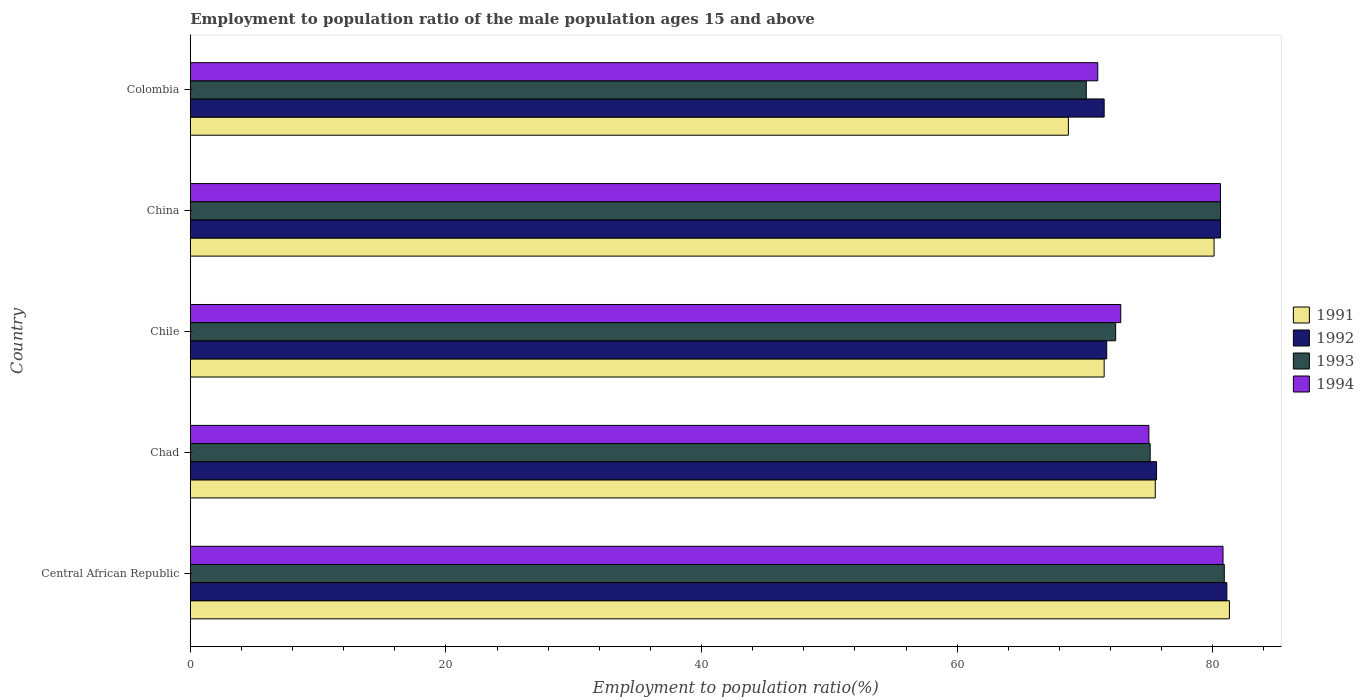How many different coloured bars are there?
Ensure brevity in your answer.  4. Are the number of bars per tick equal to the number of legend labels?
Ensure brevity in your answer.  Yes. Are the number of bars on each tick of the Y-axis equal?
Provide a short and direct response. Yes. In how many cases, is the number of bars for a given country not equal to the number of legend labels?
Provide a succinct answer. 0. Across all countries, what is the maximum employment to population ratio in 1994?
Your response must be concise. 80.8. Across all countries, what is the minimum employment to population ratio in 1993?
Keep it short and to the point. 70.1. In which country was the employment to population ratio in 1991 maximum?
Make the answer very short. Central African Republic. In which country was the employment to population ratio in 1994 minimum?
Keep it short and to the point. Colombia. What is the total employment to population ratio in 1994 in the graph?
Provide a short and direct response. 380.2. What is the difference between the employment to population ratio in 1991 in Central African Republic and that in Chile?
Make the answer very short. 9.8. What is the difference between the employment to population ratio in 1994 in Chad and the employment to population ratio in 1991 in China?
Offer a terse response. -5.1. What is the average employment to population ratio in 1992 per country?
Your answer should be very brief. 76.1. What is the difference between the employment to population ratio in 1993 and employment to population ratio in 1991 in Chile?
Your answer should be very brief. 0.9. What is the ratio of the employment to population ratio in 1991 in Central African Republic to that in Colombia?
Provide a short and direct response. 1.18. Is the difference between the employment to population ratio in 1993 in Central African Republic and Chad greater than the difference between the employment to population ratio in 1991 in Central African Republic and Chad?
Offer a very short reply. Yes. What is the difference between the highest and the second highest employment to population ratio in 1991?
Offer a terse response. 1.2. What is the difference between the highest and the lowest employment to population ratio in 1993?
Keep it short and to the point. 10.8. In how many countries, is the employment to population ratio in 1994 greater than the average employment to population ratio in 1994 taken over all countries?
Your answer should be very brief. 2. Is the sum of the employment to population ratio in 1991 in Chad and Chile greater than the maximum employment to population ratio in 1992 across all countries?
Provide a succinct answer. Yes. How many bars are there?
Give a very brief answer. 20. What is the difference between two consecutive major ticks on the X-axis?
Keep it short and to the point. 20. Does the graph contain any zero values?
Give a very brief answer. No. Does the graph contain grids?
Keep it short and to the point. No. What is the title of the graph?
Your answer should be compact. Employment to population ratio of the male population ages 15 and above. Does "1985" appear as one of the legend labels in the graph?
Provide a short and direct response. No. What is the Employment to population ratio(%) in 1991 in Central African Republic?
Give a very brief answer. 81.3. What is the Employment to population ratio(%) in 1992 in Central African Republic?
Give a very brief answer. 81.1. What is the Employment to population ratio(%) in 1993 in Central African Republic?
Give a very brief answer. 80.9. What is the Employment to population ratio(%) of 1994 in Central African Republic?
Provide a succinct answer. 80.8. What is the Employment to population ratio(%) in 1991 in Chad?
Make the answer very short. 75.5. What is the Employment to population ratio(%) in 1992 in Chad?
Offer a terse response. 75.6. What is the Employment to population ratio(%) of 1993 in Chad?
Ensure brevity in your answer.  75.1. What is the Employment to population ratio(%) in 1991 in Chile?
Ensure brevity in your answer.  71.5. What is the Employment to population ratio(%) in 1992 in Chile?
Offer a very short reply. 71.7. What is the Employment to population ratio(%) of 1993 in Chile?
Ensure brevity in your answer.  72.4. What is the Employment to population ratio(%) in 1994 in Chile?
Offer a very short reply. 72.8. What is the Employment to population ratio(%) in 1991 in China?
Keep it short and to the point. 80.1. What is the Employment to population ratio(%) in 1992 in China?
Ensure brevity in your answer.  80.6. What is the Employment to population ratio(%) in 1993 in China?
Your answer should be compact. 80.6. What is the Employment to population ratio(%) of 1994 in China?
Provide a short and direct response. 80.6. What is the Employment to population ratio(%) in 1991 in Colombia?
Your answer should be compact. 68.7. What is the Employment to population ratio(%) in 1992 in Colombia?
Ensure brevity in your answer.  71.5. What is the Employment to population ratio(%) in 1993 in Colombia?
Offer a very short reply. 70.1. What is the Employment to population ratio(%) of 1994 in Colombia?
Provide a short and direct response. 71. Across all countries, what is the maximum Employment to population ratio(%) of 1991?
Keep it short and to the point. 81.3. Across all countries, what is the maximum Employment to population ratio(%) of 1992?
Make the answer very short. 81.1. Across all countries, what is the maximum Employment to population ratio(%) of 1993?
Provide a succinct answer. 80.9. Across all countries, what is the maximum Employment to population ratio(%) in 1994?
Provide a short and direct response. 80.8. Across all countries, what is the minimum Employment to population ratio(%) of 1991?
Your answer should be very brief. 68.7. Across all countries, what is the minimum Employment to population ratio(%) in 1992?
Your answer should be very brief. 71.5. Across all countries, what is the minimum Employment to population ratio(%) in 1993?
Make the answer very short. 70.1. Across all countries, what is the minimum Employment to population ratio(%) in 1994?
Keep it short and to the point. 71. What is the total Employment to population ratio(%) in 1991 in the graph?
Keep it short and to the point. 377.1. What is the total Employment to population ratio(%) of 1992 in the graph?
Ensure brevity in your answer.  380.5. What is the total Employment to population ratio(%) in 1993 in the graph?
Offer a very short reply. 379.1. What is the total Employment to population ratio(%) of 1994 in the graph?
Offer a very short reply. 380.2. What is the difference between the Employment to population ratio(%) of 1991 in Central African Republic and that in Chad?
Give a very brief answer. 5.8. What is the difference between the Employment to population ratio(%) in 1992 in Central African Republic and that in Chile?
Ensure brevity in your answer.  9.4. What is the difference between the Employment to population ratio(%) in 1991 in Central African Republic and that in China?
Provide a succinct answer. 1.2. What is the difference between the Employment to population ratio(%) in 1994 in Central African Republic and that in China?
Your answer should be compact. 0.2. What is the difference between the Employment to population ratio(%) of 1993 in Central African Republic and that in Colombia?
Ensure brevity in your answer.  10.8. What is the difference between the Employment to population ratio(%) in 1994 in Central African Republic and that in Colombia?
Offer a very short reply. 9.8. What is the difference between the Employment to population ratio(%) of 1993 in Chad and that in Chile?
Make the answer very short. 2.7. What is the difference between the Employment to population ratio(%) of 1991 in Chad and that in China?
Offer a terse response. -4.6. What is the difference between the Employment to population ratio(%) in 1992 in Chad and that in China?
Offer a very short reply. -5. What is the difference between the Employment to population ratio(%) of 1993 in Chad and that in China?
Your response must be concise. -5.5. What is the difference between the Employment to population ratio(%) in 1992 in Chile and that in China?
Ensure brevity in your answer.  -8.9. What is the difference between the Employment to population ratio(%) of 1993 in Chile and that in China?
Keep it short and to the point. -8.2. What is the difference between the Employment to population ratio(%) of 1991 in Chile and that in Colombia?
Ensure brevity in your answer.  2.8. What is the difference between the Employment to population ratio(%) in 1993 in Chile and that in Colombia?
Your response must be concise. 2.3. What is the difference between the Employment to population ratio(%) of 1994 in Chile and that in Colombia?
Offer a terse response. 1.8. What is the difference between the Employment to population ratio(%) of 1991 in China and that in Colombia?
Offer a terse response. 11.4. What is the difference between the Employment to population ratio(%) in 1992 in China and that in Colombia?
Provide a succinct answer. 9.1. What is the difference between the Employment to population ratio(%) in 1993 in China and that in Colombia?
Offer a very short reply. 10.5. What is the difference between the Employment to population ratio(%) in 1994 in China and that in Colombia?
Ensure brevity in your answer.  9.6. What is the difference between the Employment to population ratio(%) in 1991 in Central African Republic and the Employment to population ratio(%) in 1992 in Chad?
Provide a succinct answer. 5.7. What is the difference between the Employment to population ratio(%) of 1992 in Central African Republic and the Employment to population ratio(%) of 1993 in Chad?
Make the answer very short. 6. What is the difference between the Employment to population ratio(%) of 1991 in Central African Republic and the Employment to population ratio(%) of 1993 in Chile?
Ensure brevity in your answer.  8.9. What is the difference between the Employment to population ratio(%) in 1992 in Central African Republic and the Employment to population ratio(%) in 1993 in Chile?
Offer a very short reply. 8.7. What is the difference between the Employment to population ratio(%) of 1993 in Central African Republic and the Employment to population ratio(%) of 1994 in Chile?
Ensure brevity in your answer.  8.1. What is the difference between the Employment to population ratio(%) of 1991 in Central African Republic and the Employment to population ratio(%) of 1992 in China?
Keep it short and to the point. 0.7. What is the difference between the Employment to population ratio(%) in 1991 in Central African Republic and the Employment to population ratio(%) in 1993 in China?
Offer a terse response. 0.7. What is the difference between the Employment to population ratio(%) of 1991 in Central African Republic and the Employment to population ratio(%) of 1994 in China?
Provide a short and direct response. 0.7. What is the difference between the Employment to population ratio(%) of 1992 in Central African Republic and the Employment to population ratio(%) of 1994 in Colombia?
Your answer should be very brief. 10.1. What is the difference between the Employment to population ratio(%) of 1991 in Chad and the Employment to population ratio(%) of 1992 in Chile?
Your answer should be compact. 3.8. What is the difference between the Employment to population ratio(%) of 1992 in Chad and the Employment to population ratio(%) of 1994 in Chile?
Offer a very short reply. 2.8. What is the difference between the Employment to population ratio(%) in 1991 in Chad and the Employment to population ratio(%) in 1994 in China?
Make the answer very short. -5.1. What is the difference between the Employment to population ratio(%) in 1991 in Chad and the Employment to population ratio(%) in 1992 in Colombia?
Keep it short and to the point. 4. What is the difference between the Employment to population ratio(%) of 1991 in Chad and the Employment to population ratio(%) of 1994 in Colombia?
Keep it short and to the point. 4.5. What is the difference between the Employment to population ratio(%) of 1992 in Chad and the Employment to population ratio(%) of 1993 in Colombia?
Your answer should be very brief. 5.5. What is the difference between the Employment to population ratio(%) in 1992 in Chad and the Employment to population ratio(%) in 1994 in Colombia?
Your response must be concise. 4.6. What is the difference between the Employment to population ratio(%) in 1991 in Chile and the Employment to population ratio(%) in 1992 in China?
Your answer should be very brief. -9.1. What is the difference between the Employment to population ratio(%) of 1991 in Chile and the Employment to population ratio(%) of 1993 in China?
Keep it short and to the point. -9.1. What is the difference between the Employment to population ratio(%) in 1992 in Chile and the Employment to population ratio(%) in 1993 in China?
Offer a very short reply. -8.9. What is the difference between the Employment to population ratio(%) in 1992 in Chile and the Employment to population ratio(%) in 1994 in China?
Offer a very short reply. -8.9. What is the difference between the Employment to population ratio(%) of 1993 in Chile and the Employment to population ratio(%) of 1994 in China?
Offer a very short reply. -8.2. What is the difference between the Employment to population ratio(%) in 1991 in Chile and the Employment to population ratio(%) in 1992 in Colombia?
Keep it short and to the point. 0. What is the difference between the Employment to population ratio(%) of 1991 in Chile and the Employment to population ratio(%) of 1993 in Colombia?
Give a very brief answer. 1.4. What is the difference between the Employment to population ratio(%) in 1991 in Chile and the Employment to population ratio(%) in 1994 in Colombia?
Provide a short and direct response. 0.5. What is the difference between the Employment to population ratio(%) of 1992 in Chile and the Employment to population ratio(%) of 1993 in Colombia?
Give a very brief answer. 1.6. What is the difference between the Employment to population ratio(%) in 1993 in Chile and the Employment to population ratio(%) in 1994 in Colombia?
Make the answer very short. 1.4. What is the difference between the Employment to population ratio(%) in 1991 in China and the Employment to population ratio(%) in 1993 in Colombia?
Provide a succinct answer. 10. What is the difference between the Employment to population ratio(%) of 1991 in China and the Employment to population ratio(%) of 1994 in Colombia?
Give a very brief answer. 9.1. What is the difference between the Employment to population ratio(%) in 1992 in China and the Employment to population ratio(%) in 1993 in Colombia?
Make the answer very short. 10.5. What is the difference between the Employment to population ratio(%) in 1992 in China and the Employment to population ratio(%) in 1994 in Colombia?
Offer a very short reply. 9.6. What is the average Employment to population ratio(%) of 1991 per country?
Ensure brevity in your answer.  75.42. What is the average Employment to population ratio(%) in 1992 per country?
Offer a very short reply. 76.1. What is the average Employment to population ratio(%) of 1993 per country?
Ensure brevity in your answer.  75.82. What is the average Employment to population ratio(%) in 1994 per country?
Offer a terse response. 76.04. What is the difference between the Employment to population ratio(%) of 1991 and Employment to population ratio(%) of 1994 in Central African Republic?
Keep it short and to the point. 0.5. What is the difference between the Employment to population ratio(%) of 1992 and Employment to population ratio(%) of 1993 in Central African Republic?
Your answer should be compact. 0.2. What is the difference between the Employment to population ratio(%) of 1992 and Employment to population ratio(%) of 1994 in Central African Republic?
Offer a very short reply. 0.3. What is the difference between the Employment to population ratio(%) in 1991 and Employment to population ratio(%) in 1992 in Chad?
Provide a short and direct response. -0.1. What is the difference between the Employment to population ratio(%) in 1991 and Employment to population ratio(%) in 1993 in Chile?
Your answer should be very brief. -0.9. What is the difference between the Employment to population ratio(%) in 1992 and Employment to population ratio(%) in 1993 in Chile?
Your answer should be compact. -0.7. What is the difference between the Employment to population ratio(%) in 1992 and Employment to population ratio(%) in 1994 in Chile?
Give a very brief answer. -1.1. What is the difference between the Employment to population ratio(%) of 1993 and Employment to population ratio(%) of 1994 in Chile?
Provide a succinct answer. -0.4. What is the difference between the Employment to population ratio(%) in 1992 and Employment to population ratio(%) in 1994 in China?
Your answer should be compact. 0. What is the difference between the Employment to population ratio(%) of 1991 and Employment to population ratio(%) of 1992 in Colombia?
Offer a terse response. -2.8. What is the difference between the Employment to population ratio(%) in 1991 and Employment to population ratio(%) in 1993 in Colombia?
Keep it short and to the point. -1.4. What is the difference between the Employment to population ratio(%) in 1991 and Employment to population ratio(%) in 1994 in Colombia?
Your answer should be compact. -2.3. What is the difference between the Employment to population ratio(%) of 1992 and Employment to population ratio(%) of 1994 in Colombia?
Keep it short and to the point. 0.5. What is the ratio of the Employment to population ratio(%) of 1991 in Central African Republic to that in Chad?
Make the answer very short. 1.08. What is the ratio of the Employment to population ratio(%) of 1992 in Central African Republic to that in Chad?
Your response must be concise. 1.07. What is the ratio of the Employment to population ratio(%) of 1993 in Central African Republic to that in Chad?
Provide a short and direct response. 1.08. What is the ratio of the Employment to population ratio(%) in 1994 in Central African Republic to that in Chad?
Your answer should be very brief. 1.08. What is the ratio of the Employment to population ratio(%) of 1991 in Central African Republic to that in Chile?
Your response must be concise. 1.14. What is the ratio of the Employment to population ratio(%) in 1992 in Central African Republic to that in Chile?
Offer a very short reply. 1.13. What is the ratio of the Employment to population ratio(%) of 1993 in Central African Republic to that in Chile?
Keep it short and to the point. 1.12. What is the ratio of the Employment to population ratio(%) of 1994 in Central African Republic to that in Chile?
Offer a terse response. 1.11. What is the ratio of the Employment to population ratio(%) in 1991 in Central African Republic to that in China?
Make the answer very short. 1.01. What is the ratio of the Employment to population ratio(%) in 1992 in Central African Republic to that in China?
Ensure brevity in your answer.  1.01. What is the ratio of the Employment to population ratio(%) in 1991 in Central African Republic to that in Colombia?
Your answer should be very brief. 1.18. What is the ratio of the Employment to population ratio(%) of 1992 in Central African Republic to that in Colombia?
Offer a very short reply. 1.13. What is the ratio of the Employment to population ratio(%) of 1993 in Central African Republic to that in Colombia?
Provide a short and direct response. 1.15. What is the ratio of the Employment to population ratio(%) in 1994 in Central African Republic to that in Colombia?
Keep it short and to the point. 1.14. What is the ratio of the Employment to population ratio(%) of 1991 in Chad to that in Chile?
Your answer should be very brief. 1.06. What is the ratio of the Employment to population ratio(%) of 1992 in Chad to that in Chile?
Give a very brief answer. 1.05. What is the ratio of the Employment to population ratio(%) in 1993 in Chad to that in Chile?
Ensure brevity in your answer.  1.04. What is the ratio of the Employment to population ratio(%) in 1994 in Chad to that in Chile?
Offer a very short reply. 1.03. What is the ratio of the Employment to population ratio(%) of 1991 in Chad to that in China?
Provide a succinct answer. 0.94. What is the ratio of the Employment to population ratio(%) of 1992 in Chad to that in China?
Your response must be concise. 0.94. What is the ratio of the Employment to population ratio(%) of 1993 in Chad to that in China?
Offer a very short reply. 0.93. What is the ratio of the Employment to population ratio(%) in 1994 in Chad to that in China?
Ensure brevity in your answer.  0.93. What is the ratio of the Employment to population ratio(%) of 1991 in Chad to that in Colombia?
Give a very brief answer. 1.1. What is the ratio of the Employment to population ratio(%) of 1992 in Chad to that in Colombia?
Your answer should be very brief. 1.06. What is the ratio of the Employment to population ratio(%) in 1993 in Chad to that in Colombia?
Provide a succinct answer. 1.07. What is the ratio of the Employment to population ratio(%) in 1994 in Chad to that in Colombia?
Your answer should be compact. 1.06. What is the ratio of the Employment to population ratio(%) in 1991 in Chile to that in China?
Give a very brief answer. 0.89. What is the ratio of the Employment to population ratio(%) in 1992 in Chile to that in China?
Keep it short and to the point. 0.89. What is the ratio of the Employment to population ratio(%) in 1993 in Chile to that in China?
Provide a succinct answer. 0.9. What is the ratio of the Employment to population ratio(%) in 1994 in Chile to that in China?
Ensure brevity in your answer.  0.9. What is the ratio of the Employment to population ratio(%) in 1991 in Chile to that in Colombia?
Keep it short and to the point. 1.04. What is the ratio of the Employment to population ratio(%) of 1992 in Chile to that in Colombia?
Give a very brief answer. 1. What is the ratio of the Employment to population ratio(%) in 1993 in Chile to that in Colombia?
Your answer should be very brief. 1.03. What is the ratio of the Employment to population ratio(%) in 1994 in Chile to that in Colombia?
Provide a succinct answer. 1.03. What is the ratio of the Employment to population ratio(%) of 1991 in China to that in Colombia?
Offer a very short reply. 1.17. What is the ratio of the Employment to population ratio(%) in 1992 in China to that in Colombia?
Your answer should be compact. 1.13. What is the ratio of the Employment to population ratio(%) of 1993 in China to that in Colombia?
Your answer should be very brief. 1.15. What is the ratio of the Employment to population ratio(%) in 1994 in China to that in Colombia?
Provide a succinct answer. 1.14. What is the difference between the highest and the second highest Employment to population ratio(%) of 1992?
Keep it short and to the point. 0.5. What is the difference between the highest and the second highest Employment to population ratio(%) of 1993?
Make the answer very short. 0.3. What is the difference between the highest and the second highest Employment to population ratio(%) in 1994?
Offer a terse response. 0.2. What is the difference between the highest and the lowest Employment to population ratio(%) of 1991?
Make the answer very short. 12.6. 